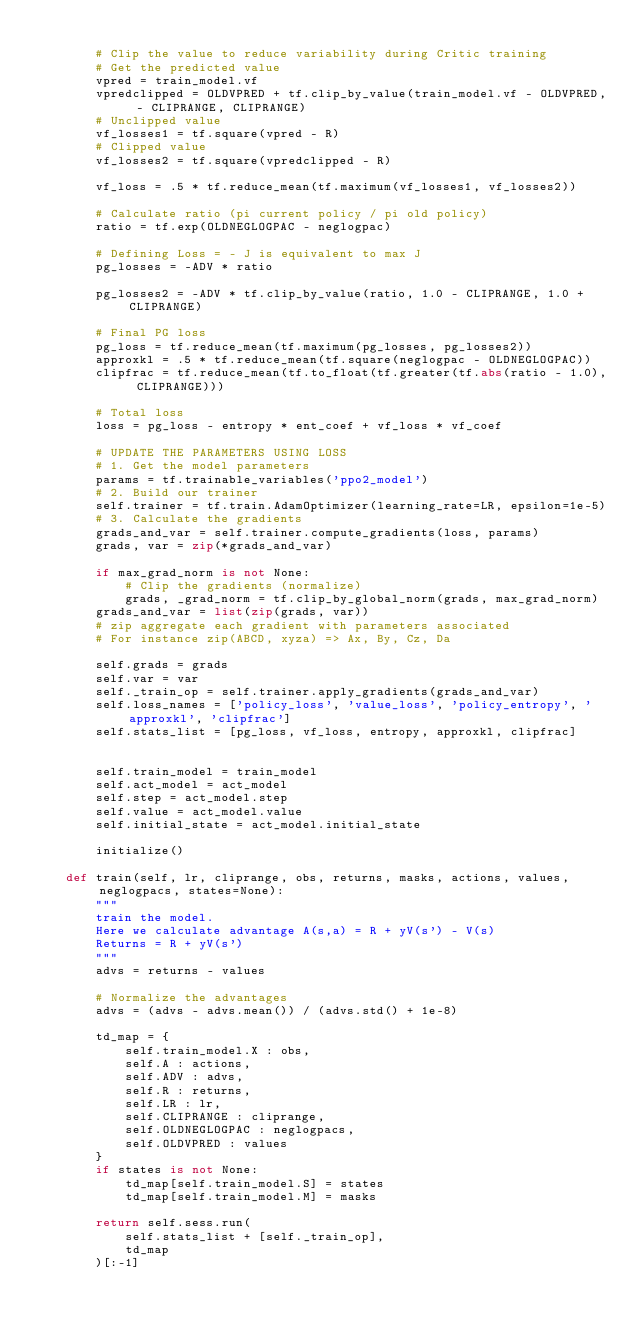Convert code to text. <code><loc_0><loc_0><loc_500><loc_500><_Python_>
        # Clip the value to reduce variability during Critic training
        # Get the predicted value
        vpred = train_model.vf
        vpredclipped = OLDVPRED + tf.clip_by_value(train_model.vf - OLDVPRED, - CLIPRANGE, CLIPRANGE)
        # Unclipped value
        vf_losses1 = tf.square(vpred - R)
        # Clipped value
        vf_losses2 = tf.square(vpredclipped - R)

        vf_loss = .5 * tf.reduce_mean(tf.maximum(vf_losses1, vf_losses2))

        # Calculate ratio (pi current policy / pi old policy)
        ratio = tf.exp(OLDNEGLOGPAC - neglogpac)

        # Defining Loss = - J is equivalent to max J
        pg_losses = -ADV * ratio

        pg_losses2 = -ADV * tf.clip_by_value(ratio, 1.0 - CLIPRANGE, 1.0 + CLIPRANGE)

        # Final PG loss
        pg_loss = tf.reduce_mean(tf.maximum(pg_losses, pg_losses2))
        approxkl = .5 * tf.reduce_mean(tf.square(neglogpac - OLDNEGLOGPAC))
        clipfrac = tf.reduce_mean(tf.to_float(tf.greater(tf.abs(ratio - 1.0), CLIPRANGE)))

        # Total loss
        loss = pg_loss - entropy * ent_coef + vf_loss * vf_coef

        # UPDATE THE PARAMETERS USING LOSS
        # 1. Get the model parameters
        params = tf.trainable_variables('ppo2_model')
        # 2. Build our trainer
        self.trainer = tf.train.AdamOptimizer(learning_rate=LR, epsilon=1e-5)
        # 3. Calculate the gradients
        grads_and_var = self.trainer.compute_gradients(loss, params)
        grads, var = zip(*grads_and_var)

        if max_grad_norm is not None:
            # Clip the gradients (normalize)
            grads, _grad_norm = tf.clip_by_global_norm(grads, max_grad_norm)
        grads_and_var = list(zip(grads, var))
        # zip aggregate each gradient with parameters associated
        # For instance zip(ABCD, xyza) => Ax, By, Cz, Da

        self.grads = grads
        self.var = var
        self._train_op = self.trainer.apply_gradients(grads_and_var)
        self.loss_names = ['policy_loss', 'value_loss', 'policy_entropy', 'approxkl', 'clipfrac']
        self.stats_list = [pg_loss, vf_loss, entropy, approxkl, clipfrac]


        self.train_model = train_model
        self.act_model = act_model
        self.step = act_model.step
        self.value = act_model.value
        self.initial_state = act_model.initial_state

        initialize()

    def train(self, lr, cliprange, obs, returns, masks, actions, values, neglogpacs, states=None):
        """
        train the model.
        Here we calculate advantage A(s,a) = R + yV(s') - V(s)
        Returns = R + yV(s')
        """
        advs = returns - values

        # Normalize the advantages
        advs = (advs - advs.mean()) / (advs.std() + 1e-8)

        td_map = {
            self.train_model.X : obs,
            self.A : actions,
            self.ADV : advs,
            self.R : returns,
            self.LR : lr,
            self.CLIPRANGE : cliprange,
            self.OLDNEGLOGPAC : neglogpacs,
            self.OLDVPRED : values
        }
        if states is not None:
            td_map[self.train_model.S] = states
            td_map[self.train_model.M] = masks

        return self.sess.run(
            self.stats_list + [self._train_op],
            td_map
        )[:-1]
</code> 